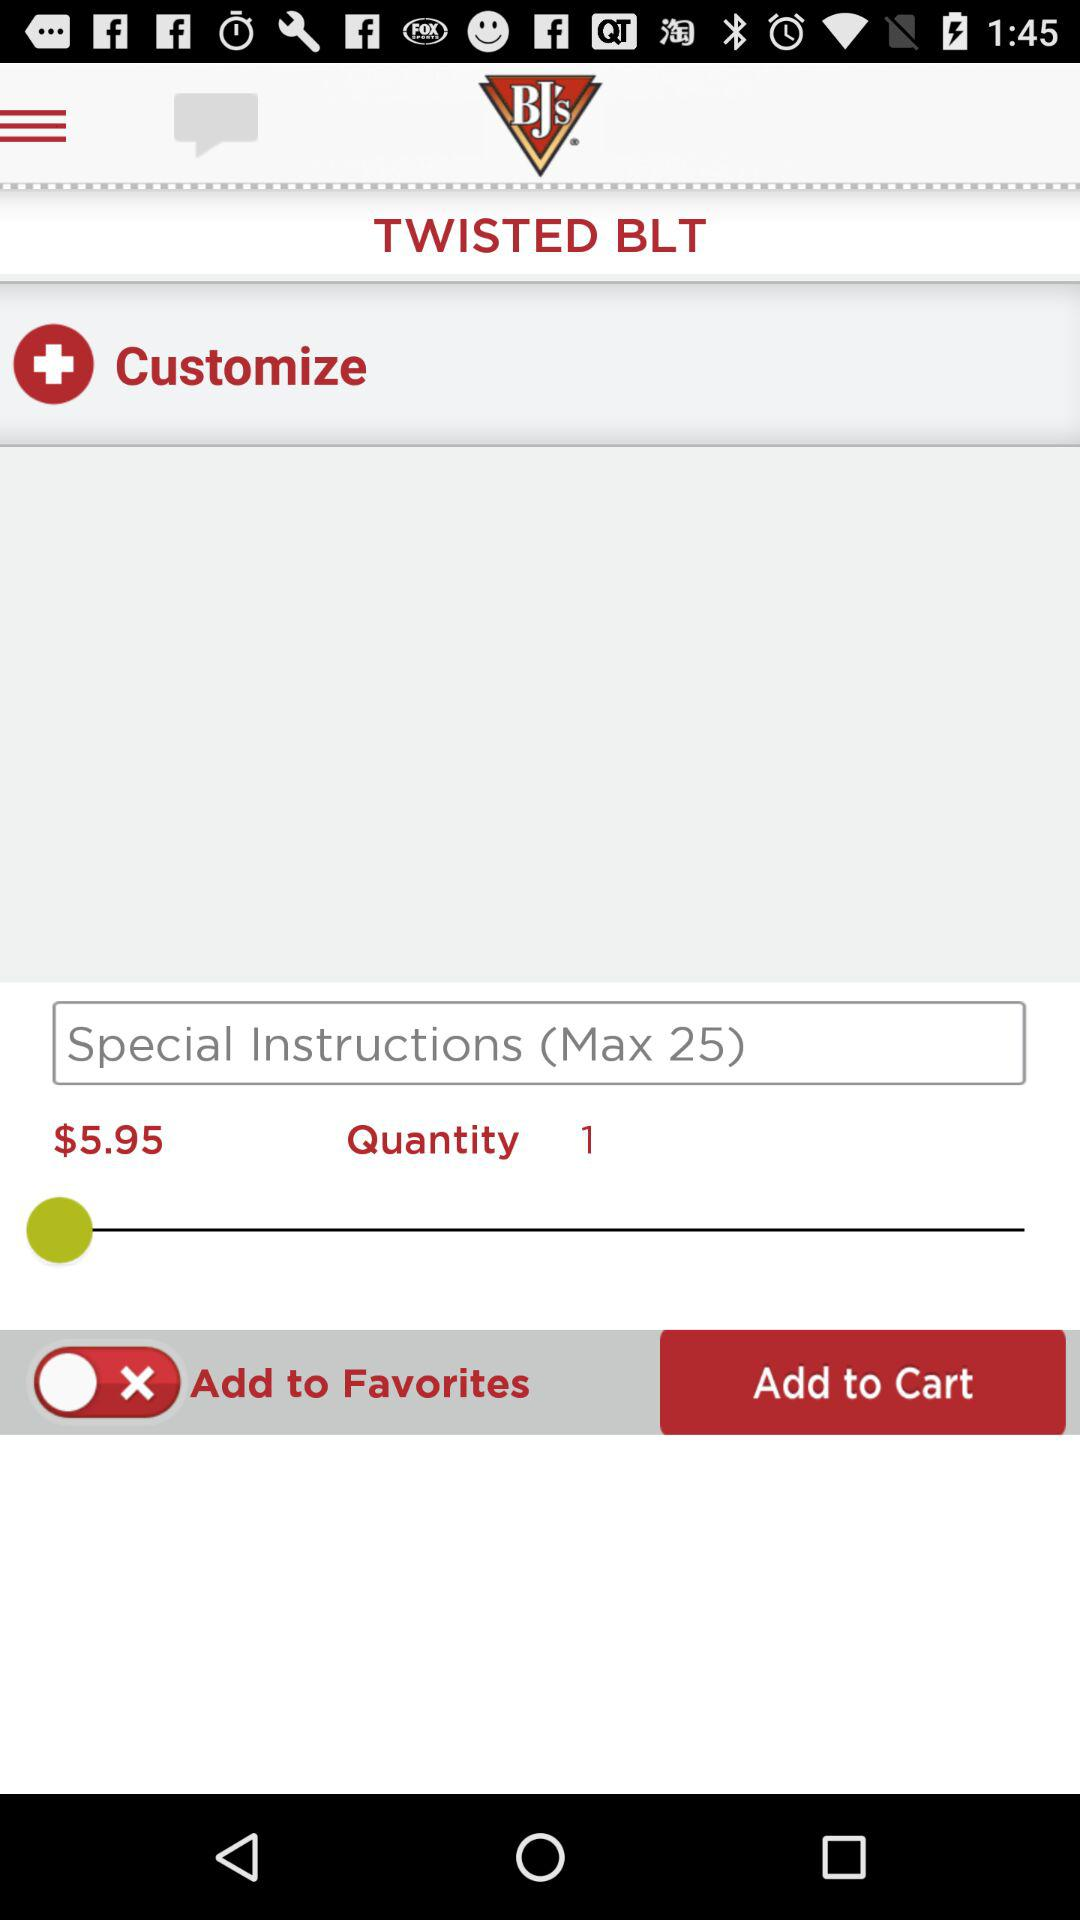What is the maximum length of special instructions? The maximum length is 25. 